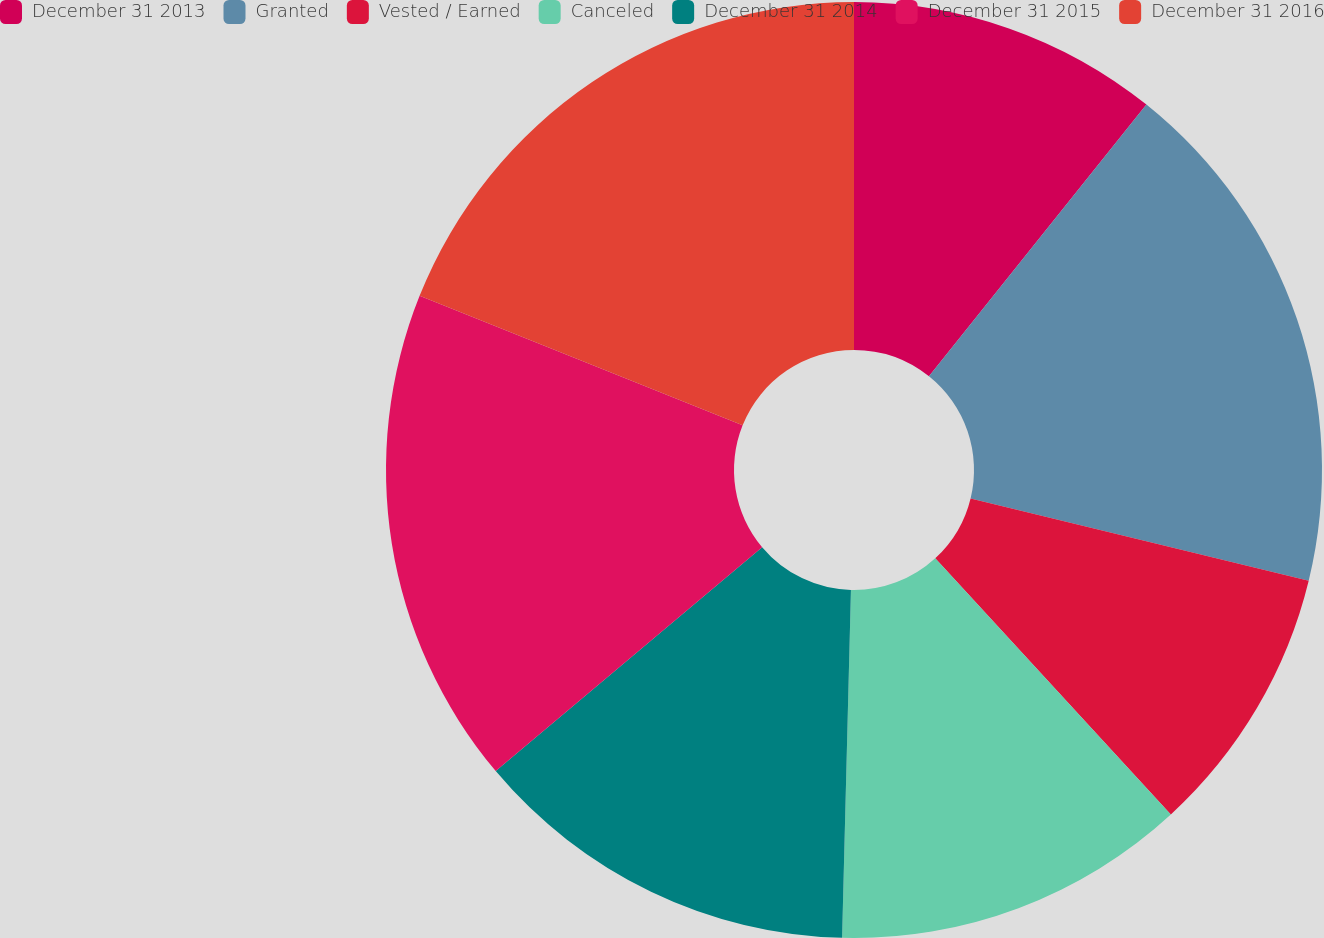Convert chart to OTSL. <chart><loc_0><loc_0><loc_500><loc_500><pie_chart><fcel>December 31 2013<fcel>Granted<fcel>Vested / Earned<fcel>Canceled<fcel>December 31 2014<fcel>December 31 2015<fcel>December 31 2016<nl><fcel>10.74%<fcel>18.06%<fcel>9.36%<fcel>12.24%<fcel>13.47%<fcel>17.19%<fcel>18.93%<nl></chart> 